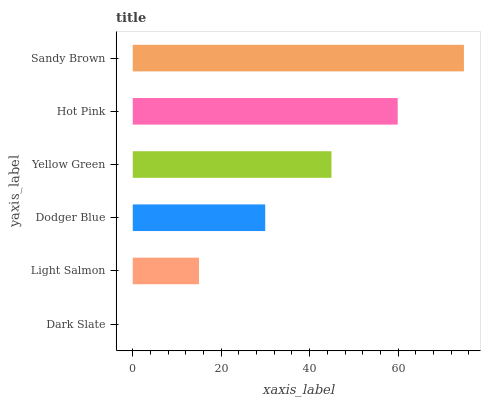Is Dark Slate the minimum?
Answer yes or no. Yes. Is Sandy Brown the maximum?
Answer yes or no. Yes. Is Light Salmon the minimum?
Answer yes or no. No. Is Light Salmon the maximum?
Answer yes or no. No. Is Light Salmon greater than Dark Slate?
Answer yes or no. Yes. Is Dark Slate less than Light Salmon?
Answer yes or no. Yes. Is Dark Slate greater than Light Salmon?
Answer yes or no. No. Is Light Salmon less than Dark Slate?
Answer yes or no. No. Is Yellow Green the high median?
Answer yes or no. Yes. Is Dodger Blue the low median?
Answer yes or no. Yes. Is Sandy Brown the high median?
Answer yes or no. No. Is Dark Slate the low median?
Answer yes or no. No. 